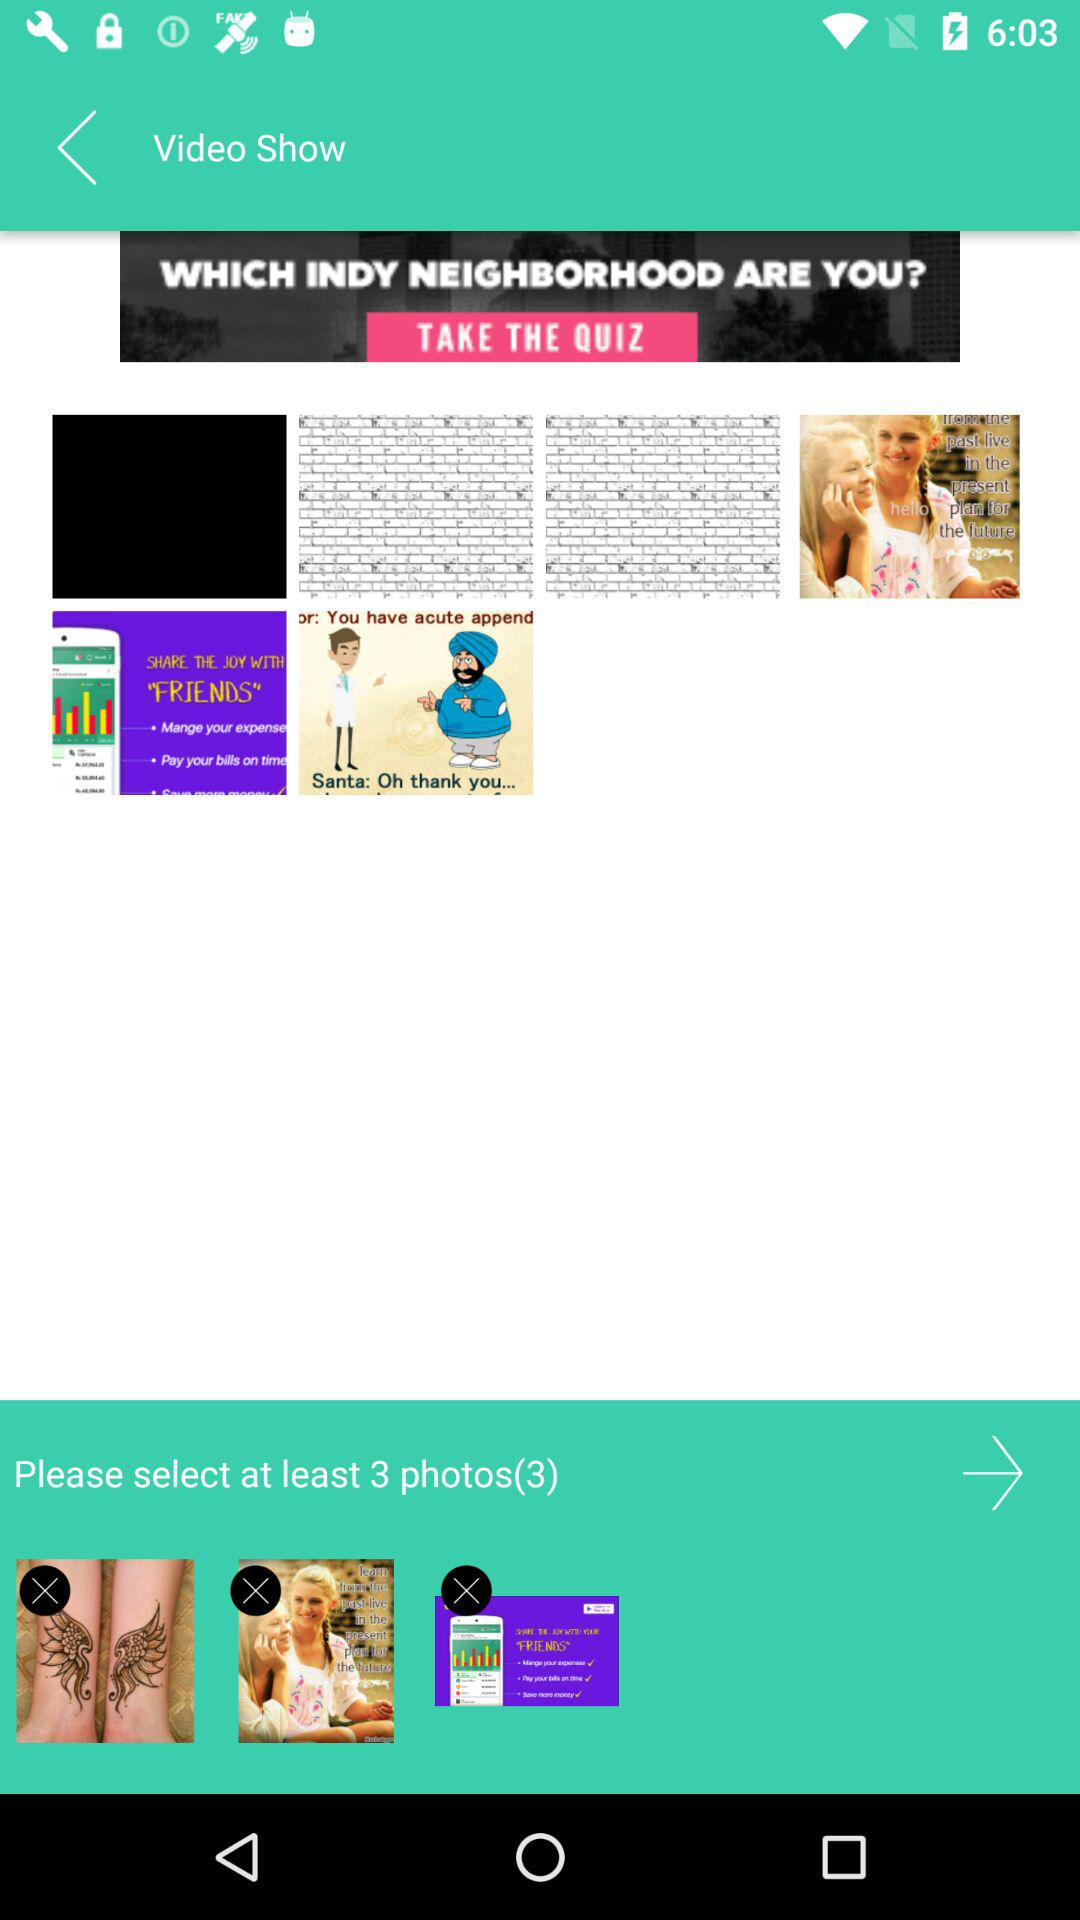How many photos do we have to select? You have to select at least 3 photos. 